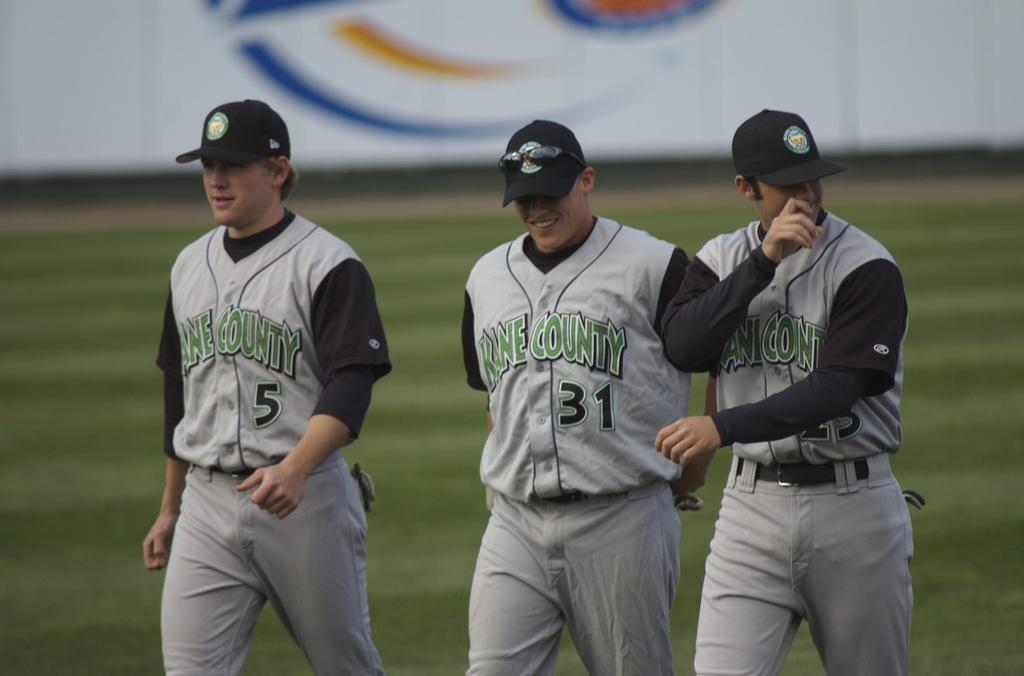Provide a one-sentence caption for the provided image. Baseball player number 31 is flanked by two teammates. 